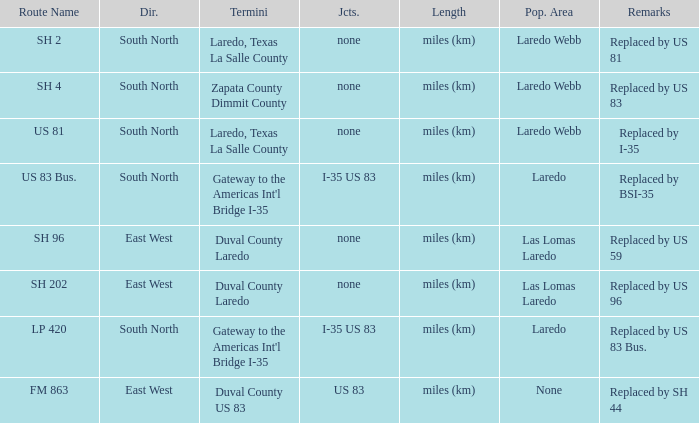How many junctions have "replaced by bsi-35" listed in their remarks section? 1.0. 